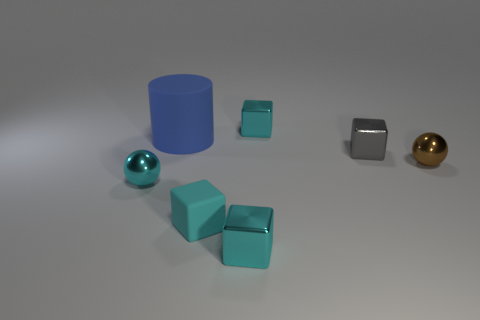How many other things are the same color as the big thing?
Give a very brief answer. 0. There is a cyan metallic thing that is on the right side of the tiny cyan ball and in front of the gray metal cube; how big is it?
Offer a very short reply. Small. Is the number of balls that are to the left of the tiny cyan metal sphere less than the number of cyan matte blocks?
Your response must be concise. Yes. Do the big thing and the tiny cyan sphere have the same material?
Provide a succinct answer. No. How many objects are either tiny blocks or big green matte things?
Ensure brevity in your answer.  4. How many blue things have the same material as the brown object?
Your answer should be very brief. 0. The matte object that is the same shape as the tiny gray metallic thing is what size?
Your response must be concise. Small. There is a gray metallic thing; are there any cyan metallic spheres behind it?
Provide a succinct answer. No. What material is the blue cylinder?
Offer a terse response. Rubber. Do the small object that is left of the large matte cylinder and the rubber cylinder have the same color?
Your response must be concise. No. 